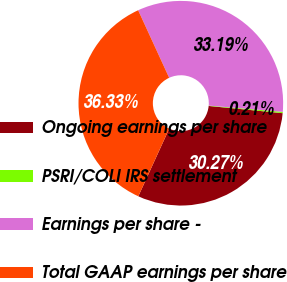<chart> <loc_0><loc_0><loc_500><loc_500><pie_chart><fcel>Ongoing earnings per share<fcel>PSRI/COLI IRS settlement<fcel>Earnings per share -<fcel>Total GAAP earnings per share<nl><fcel>30.27%<fcel>0.21%<fcel>33.19%<fcel>36.33%<nl></chart> 